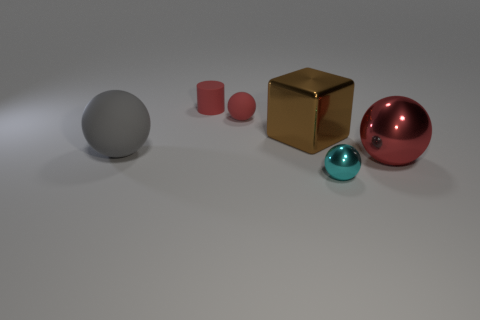Do the tiny ball behind the large gray sphere and the big object that is on the right side of the small cyan shiny object have the same color?
Your answer should be very brief. Yes. There is a red sphere that is the same size as the brown thing; what is it made of?
Your answer should be very brief. Metal. What number of objects are either big metal spheres or tiny things that are to the right of the cylinder?
Provide a short and direct response. 3. What size is the red ball that is the same material as the brown object?
Give a very brief answer. Large. There is a big shiny thing that is on the left side of the tiny object that is in front of the large brown metal block; what is its shape?
Make the answer very short. Cube. There is a object that is both in front of the large brown metallic cube and on the left side of the small cyan metallic object; how big is it?
Offer a terse response. Large. Is there a tiny red thing of the same shape as the big gray rubber object?
Make the answer very short. Yes. Are there any other things that are the same shape as the small shiny thing?
Your answer should be very brief. Yes. There is a ball that is behind the gray thing that is on the left side of the large ball to the right of the brown object; what is it made of?
Your answer should be very brief. Rubber. Is there a brown block of the same size as the gray matte thing?
Your answer should be very brief. Yes. 